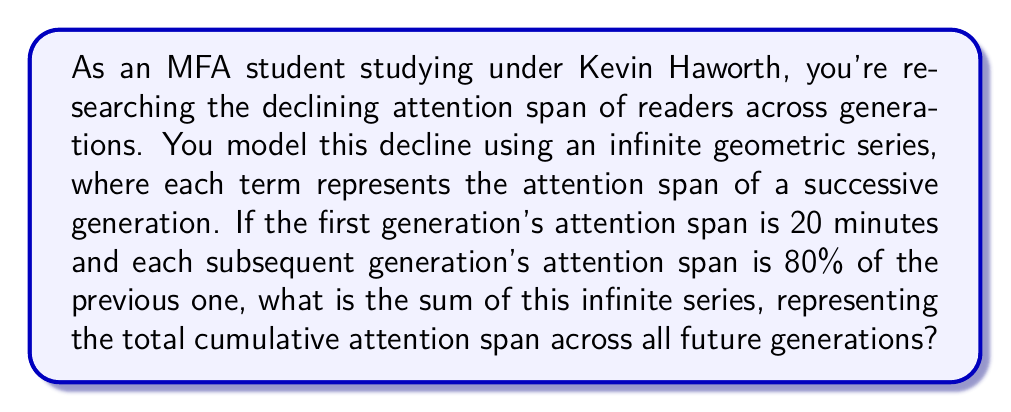Provide a solution to this math problem. Let's approach this step-by-step:

1) First, we identify the components of our geometric series:
   - First term, $a = 20$ (the first generation's attention span in minutes)
   - Common ratio, $r = 0.8$ (each generation's attention span is 80% of the previous)

2) The infinite geometric series is represented as:

   $S_{\infty} = a + ar + ar^2 + ar^3 + ...$

3) For an infinite geometric series with $|r| < 1$, the sum is given by the formula:

   $S_{\infty} = \frac{a}{1-r}$

4) In our case, $|r| = 0.8 < 1$, so we can use this formula.

5) Substituting our values:

   $S_{\infty} = \frac{20}{1-0.8}$

6) Simplify:
   
   $S_{\infty} = \frac{20}{0.2} = 100$

Therefore, the sum of the infinite series, representing the total cumulative attention span across all future generations, is 100 minutes.
Answer: 100 minutes 